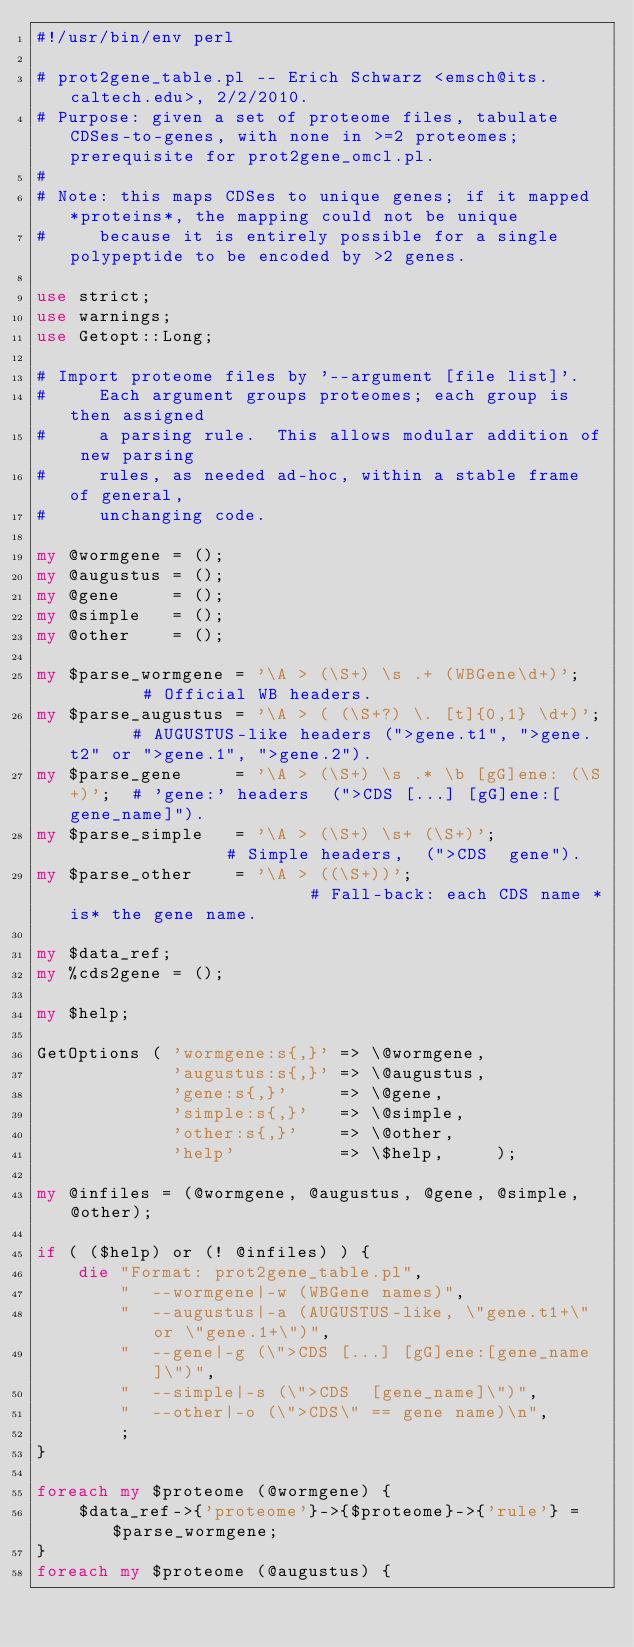<code> <loc_0><loc_0><loc_500><loc_500><_Perl_>#!/usr/bin/env perl

# prot2gene_table.pl -- Erich Schwarz <emsch@its.caltech.edu>, 2/2/2010.
# Purpose: given a set of proteome files, tabulate CDSes-to-genes, with none in >=2 proteomes; prerequisite for prot2gene_omcl.pl.
# 
# Note: this maps CDSes to unique genes; if it mapped *proteins*, the mapping could not be unique
#     because it is entirely possible for a single polypeptide to be encoded by >2 genes.

use strict;
use warnings;
use Getopt::Long;

# Import proteome files by '--argument [file list]'.
#     Each argument groups proteomes; each group is then assigned 
#     a parsing rule.  This allows modular addition of new parsing 
#     rules, as needed ad-hoc, within a stable frame of general, 
#     unchanging code.

my @wormgene = ();
my @augustus = ();
my @gene     = ();
my @simple   = ();
my @other    = ();

my $parse_wormgene = '\A > (\S+) \s .+ (WBGene\d+)';        # Official WB headers.
my $parse_augustus = '\A > ( (\S+?) \. [t]{0,1} \d+)';      # AUGUSTUS-like headers (">gene.t1", ">gene.t2" or ">gene.1", ">gene.2").
my $parse_gene     = '\A > (\S+) \s .* \b [gG]ene: (\S+)';  # 'gene:' headers  (">CDS [...] [gG]ene:[gene_name]").
my $parse_simple   = '\A > (\S+) \s+ (\S+)';                # Simple headers,  (">CDS  gene").
my $parse_other    = '\A > ((\S+))';                        # Fall-back: each CDS name *is* the gene name.

my $data_ref;
my %cds2gene = ();

my $help;

GetOptions ( 'wormgene:s{,}' => \@wormgene,
             'augustus:s{,}' => \@augustus,
             'gene:s{,}'     => \@gene,
             'simple:s{,}'   => \@simple,
             'other:s{,}'    => \@other,
             'help'          => \$help,     );

my @infiles = (@wormgene, @augustus, @gene, @simple, @other);

if ( ($help) or (! @infiles) ) { 
    die "Format: prot2gene_table.pl",
        "  --wormgene|-w (WBGene names)",
        "  --augustus|-a (AUGUSTUS-like, \"gene.t1+\" or \"gene.1+\")",
        "  --gene|-g (\">CDS [...] [gG]ene:[gene_name]\")",
        "  --simple|-s (\">CDS  [gene_name]\")",
        "  --other|-o (\">CDS\" == gene name)\n",
        ;
}

foreach my $proteome (@wormgene) { 
    $data_ref->{'proteome'}->{$proteome}->{'rule'} = $parse_wormgene;
}
foreach my $proteome (@augustus) { </code> 